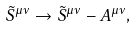Convert formula to latex. <formula><loc_0><loc_0><loc_500><loc_500>\tilde { S } ^ { \mu \nu } \rightarrow \tilde { S } ^ { \mu \nu } - A ^ { \mu \nu } ,</formula> 